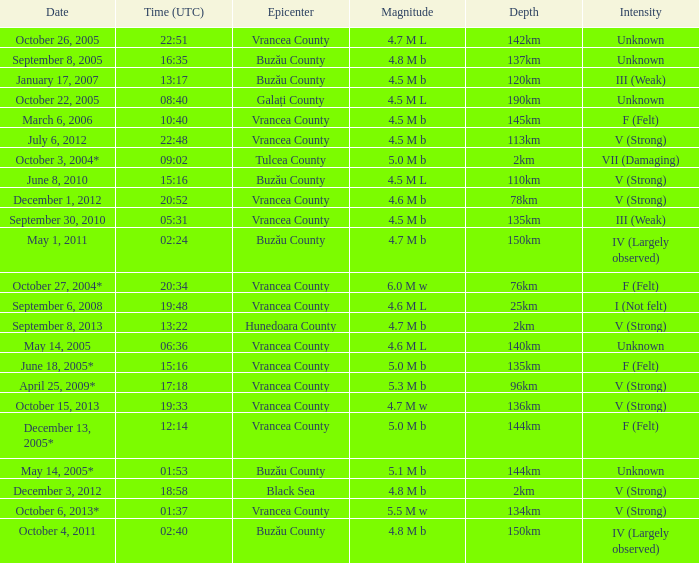What is the magnitude with epicenter at Vrancea County, unknown intensity and which happened at 06:36? 4.6 M L. 